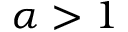<formula> <loc_0><loc_0><loc_500><loc_500>\alpha > 1</formula> 